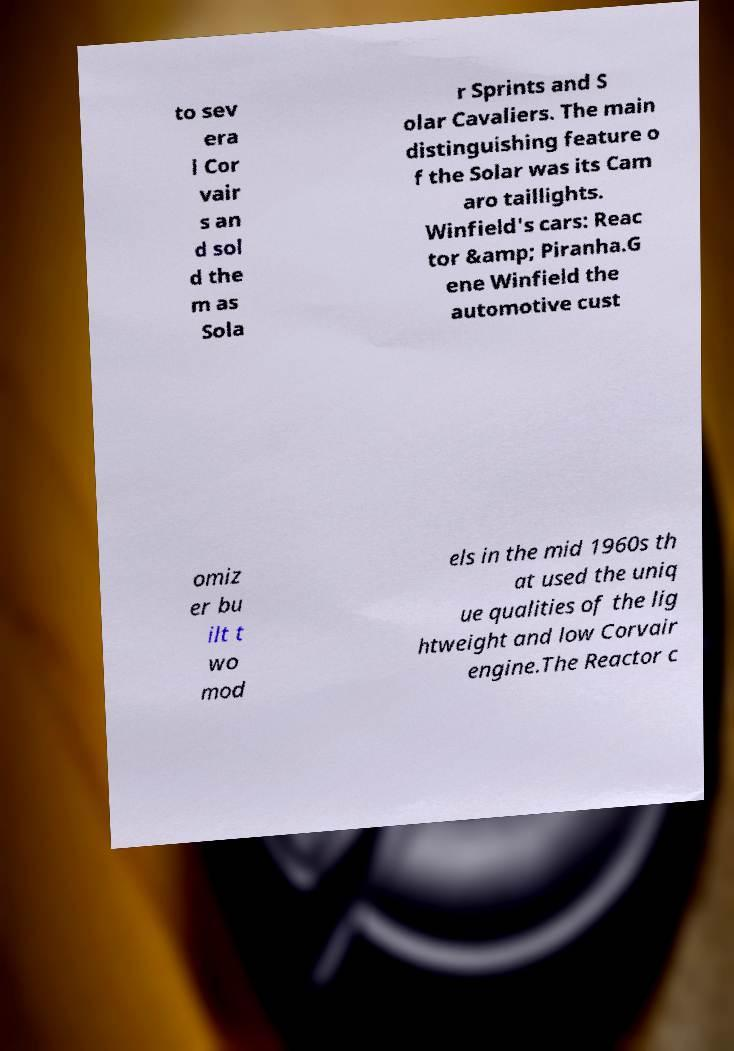What messages or text are displayed in this image? I need them in a readable, typed format. to sev era l Cor vair s an d sol d the m as Sola r Sprints and S olar Cavaliers. The main distinguishing feature o f the Solar was its Cam aro taillights. Winfield's cars: Reac tor &amp; Piranha.G ene Winfield the automotive cust omiz er bu ilt t wo mod els in the mid 1960s th at used the uniq ue qualities of the lig htweight and low Corvair engine.The Reactor c 